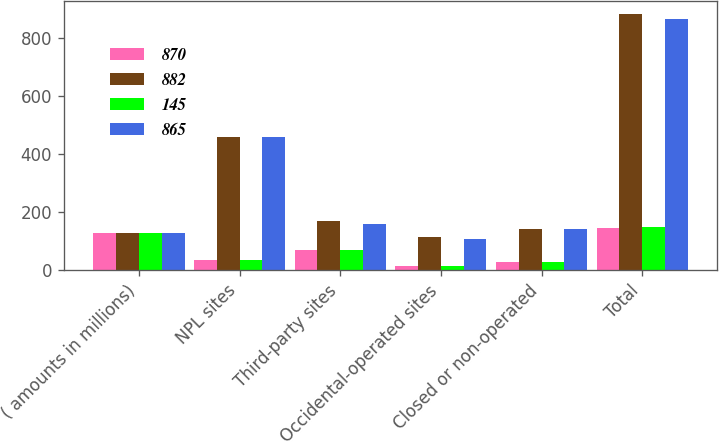<chart> <loc_0><loc_0><loc_500><loc_500><stacked_bar_chart><ecel><fcel>( amounts in millions)<fcel>NPL sites<fcel>Third-party sites<fcel>Occidental-operated sites<fcel>Closed or non-operated<fcel>Total<nl><fcel>870<fcel>128<fcel>34<fcel>68<fcel>14<fcel>29<fcel>145<nl><fcel>882<fcel>128<fcel>458<fcel>168<fcel>115<fcel>141<fcel>882<nl><fcel>145<fcel>128<fcel>34<fcel>70<fcel>15<fcel>29<fcel>148<nl><fcel>865<fcel>128<fcel>457<fcel>157<fcel>108<fcel>143<fcel>865<nl></chart> 